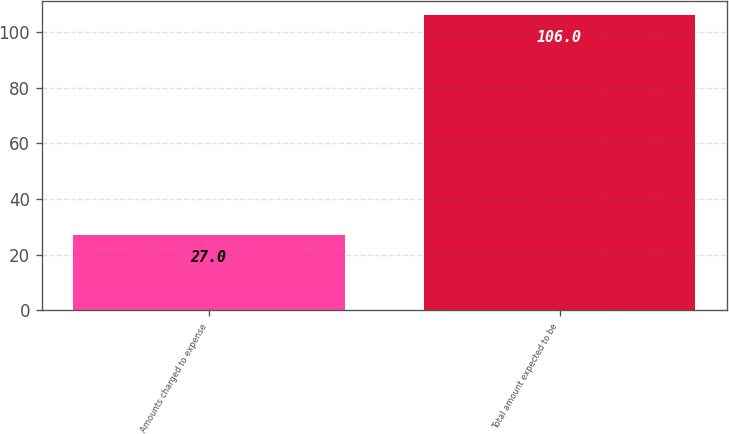Convert chart to OTSL. <chart><loc_0><loc_0><loc_500><loc_500><bar_chart><fcel>Amounts charged to expense<fcel>Total amount expected to be<nl><fcel>27<fcel>106<nl></chart> 